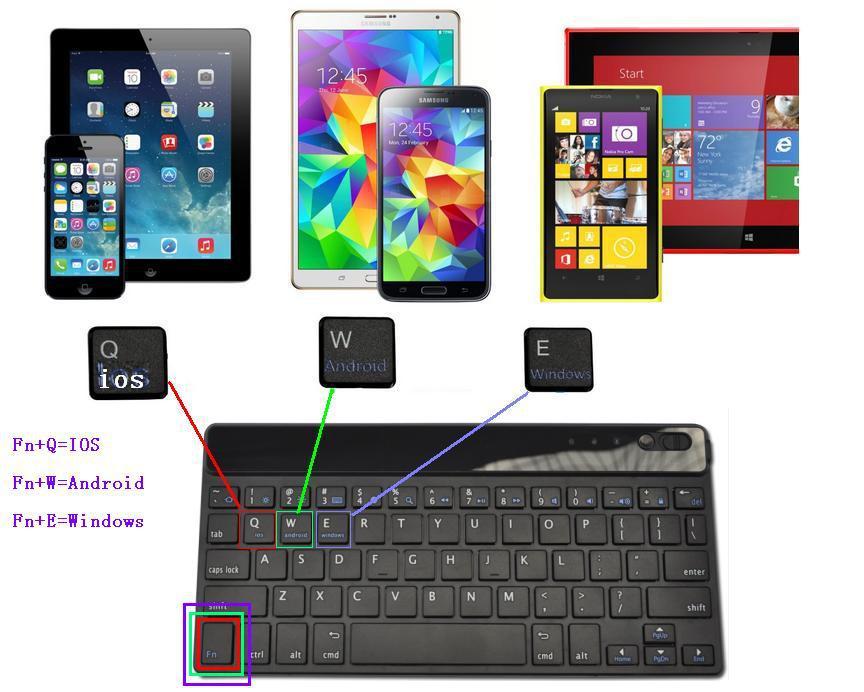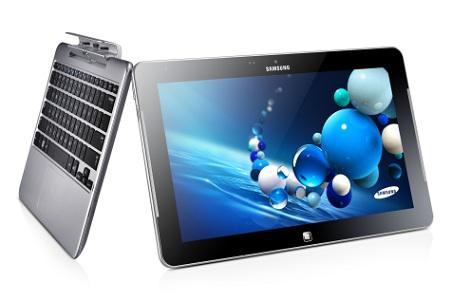The first image is the image on the left, the second image is the image on the right. Given the left and right images, does the statement "The left and right image contains the same number of laptops." hold true? Answer yes or no. No. The first image is the image on the left, the second image is the image on the right. Analyze the images presented: Is the assertion "There are at least four devices visible in each image." valid? Answer yes or no. No. 